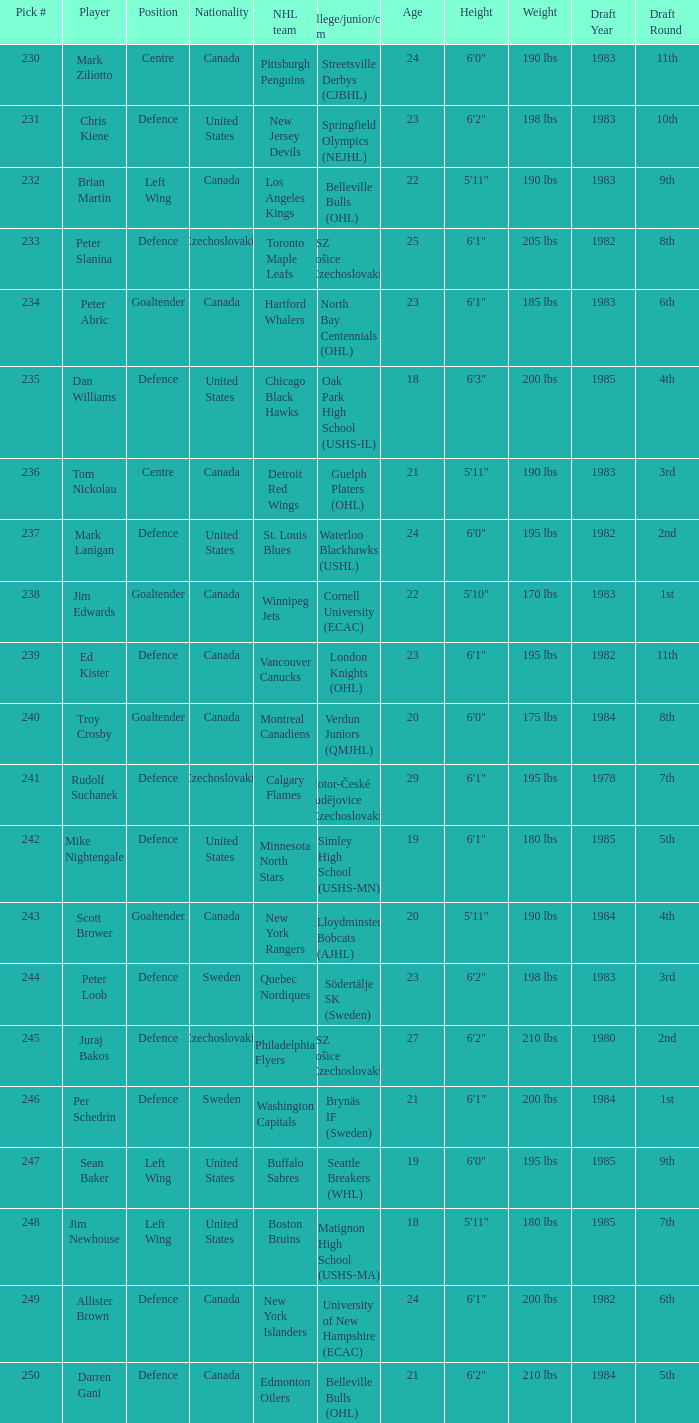What position does allister brown play. Defence. 